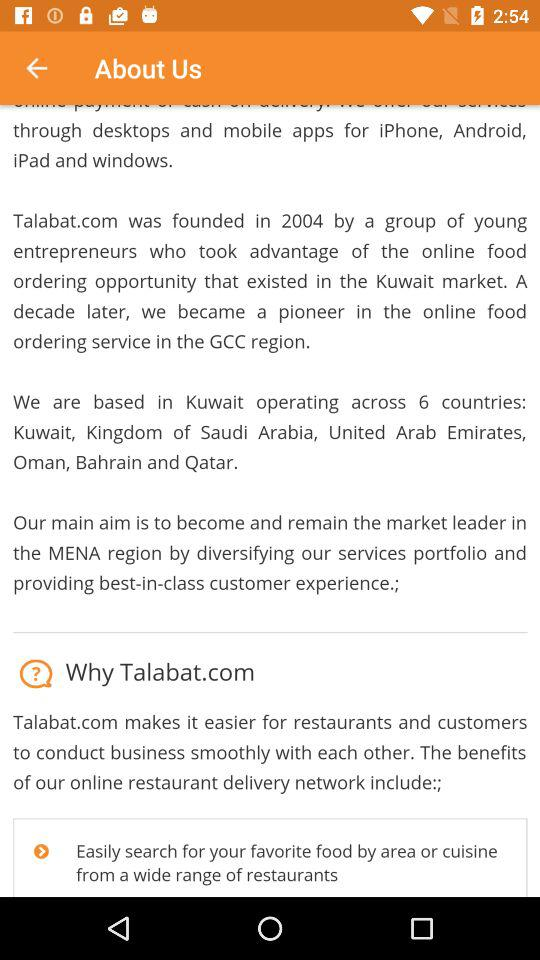How many countries does Talabat.com operate in?
Answer the question using a single word or phrase. 6 